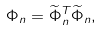Convert formula to latex. <formula><loc_0><loc_0><loc_500><loc_500>\Phi _ { n } = \widetilde { \Phi } _ { n } ^ { T } \widetilde { \Phi } _ { n } ,</formula> 